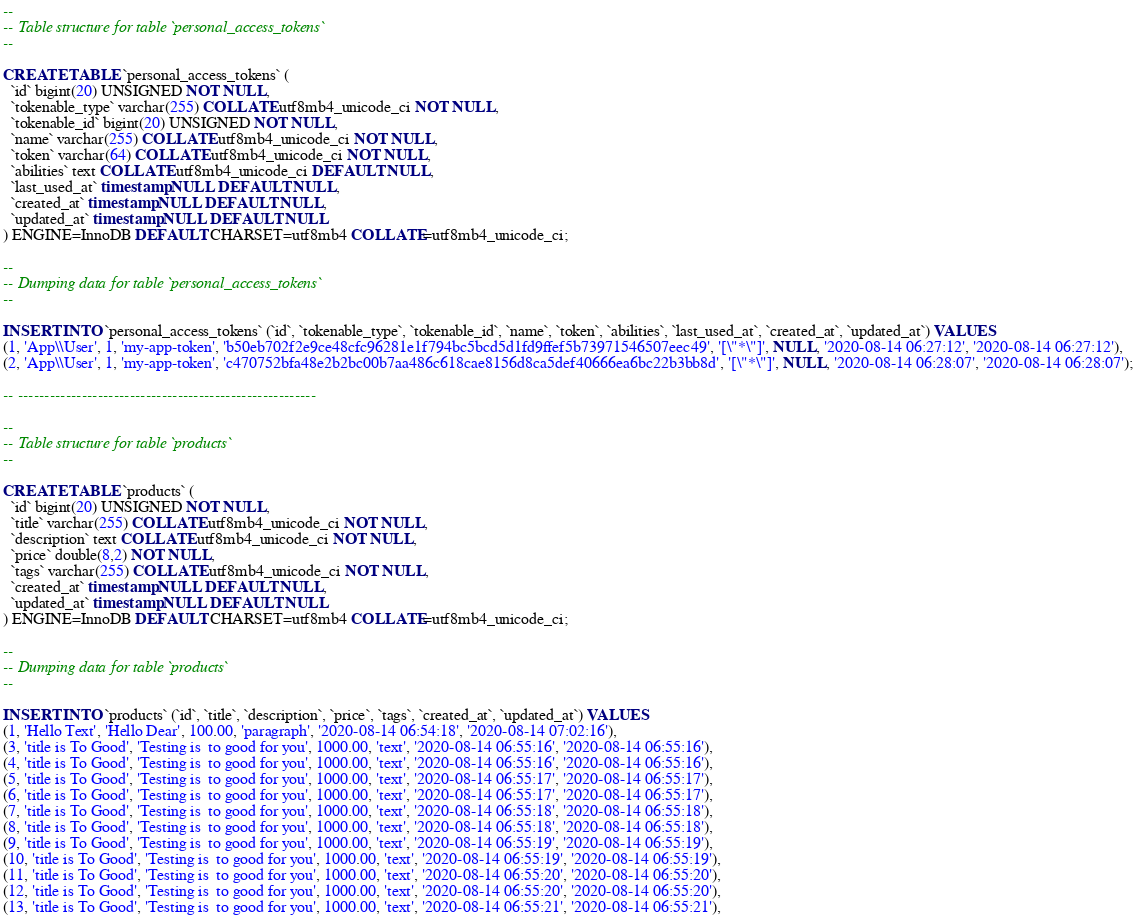<code> <loc_0><loc_0><loc_500><loc_500><_SQL_>
--
-- Table structure for table `personal_access_tokens`
--

CREATE TABLE `personal_access_tokens` (
  `id` bigint(20) UNSIGNED NOT NULL,
  `tokenable_type` varchar(255) COLLATE utf8mb4_unicode_ci NOT NULL,
  `tokenable_id` bigint(20) UNSIGNED NOT NULL,
  `name` varchar(255) COLLATE utf8mb4_unicode_ci NOT NULL,
  `token` varchar(64) COLLATE utf8mb4_unicode_ci NOT NULL,
  `abilities` text COLLATE utf8mb4_unicode_ci DEFAULT NULL,
  `last_used_at` timestamp NULL DEFAULT NULL,
  `created_at` timestamp NULL DEFAULT NULL,
  `updated_at` timestamp NULL DEFAULT NULL
) ENGINE=InnoDB DEFAULT CHARSET=utf8mb4 COLLATE=utf8mb4_unicode_ci;

--
-- Dumping data for table `personal_access_tokens`
--

INSERT INTO `personal_access_tokens` (`id`, `tokenable_type`, `tokenable_id`, `name`, `token`, `abilities`, `last_used_at`, `created_at`, `updated_at`) VALUES
(1, 'App\\User', 1, 'my-app-token', 'b50eb702f2e9ce48cfc96281e1f794bc5bcd5d1fd9ffef5b73971546507eec49', '[\"*\"]', NULL, '2020-08-14 06:27:12', '2020-08-14 06:27:12'),
(2, 'App\\User', 1, 'my-app-token', 'c470752bfa48e2b2bc00b7aa486c618cae8156d8ca5def40666ea6bc22b3bb8d', '[\"*\"]', NULL, '2020-08-14 06:28:07', '2020-08-14 06:28:07');

-- --------------------------------------------------------

--
-- Table structure for table `products`
--

CREATE TABLE `products` (
  `id` bigint(20) UNSIGNED NOT NULL,
  `title` varchar(255) COLLATE utf8mb4_unicode_ci NOT NULL,
  `description` text COLLATE utf8mb4_unicode_ci NOT NULL,
  `price` double(8,2) NOT NULL,
  `tags` varchar(255) COLLATE utf8mb4_unicode_ci NOT NULL,
  `created_at` timestamp NULL DEFAULT NULL,
  `updated_at` timestamp NULL DEFAULT NULL
) ENGINE=InnoDB DEFAULT CHARSET=utf8mb4 COLLATE=utf8mb4_unicode_ci;

--
-- Dumping data for table `products`
--

INSERT INTO `products` (`id`, `title`, `description`, `price`, `tags`, `created_at`, `updated_at`) VALUES
(1, 'Hello Text', 'Hello Dear', 100.00, 'paragraph', '2020-08-14 06:54:18', '2020-08-14 07:02:16'),
(3, 'title is To Good', 'Testing is  to good for you', 1000.00, 'text', '2020-08-14 06:55:16', '2020-08-14 06:55:16'),
(4, 'title is To Good', 'Testing is  to good for you', 1000.00, 'text', '2020-08-14 06:55:16', '2020-08-14 06:55:16'),
(5, 'title is To Good', 'Testing is  to good for you', 1000.00, 'text', '2020-08-14 06:55:17', '2020-08-14 06:55:17'),
(6, 'title is To Good', 'Testing is  to good for you', 1000.00, 'text', '2020-08-14 06:55:17', '2020-08-14 06:55:17'),
(7, 'title is To Good', 'Testing is  to good for you', 1000.00, 'text', '2020-08-14 06:55:18', '2020-08-14 06:55:18'),
(8, 'title is To Good', 'Testing is  to good for you', 1000.00, 'text', '2020-08-14 06:55:18', '2020-08-14 06:55:18'),
(9, 'title is To Good', 'Testing is  to good for you', 1000.00, 'text', '2020-08-14 06:55:19', '2020-08-14 06:55:19'),
(10, 'title is To Good', 'Testing is  to good for you', 1000.00, 'text', '2020-08-14 06:55:19', '2020-08-14 06:55:19'),
(11, 'title is To Good', 'Testing is  to good for you', 1000.00, 'text', '2020-08-14 06:55:20', '2020-08-14 06:55:20'),
(12, 'title is To Good', 'Testing is  to good for you', 1000.00, 'text', '2020-08-14 06:55:20', '2020-08-14 06:55:20'),
(13, 'title is To Good', 'Testing is  to good for you', 1000.00, 'text', '2020-08-14 06:55:21', '2020-08-14 06:55:21'),</code> 